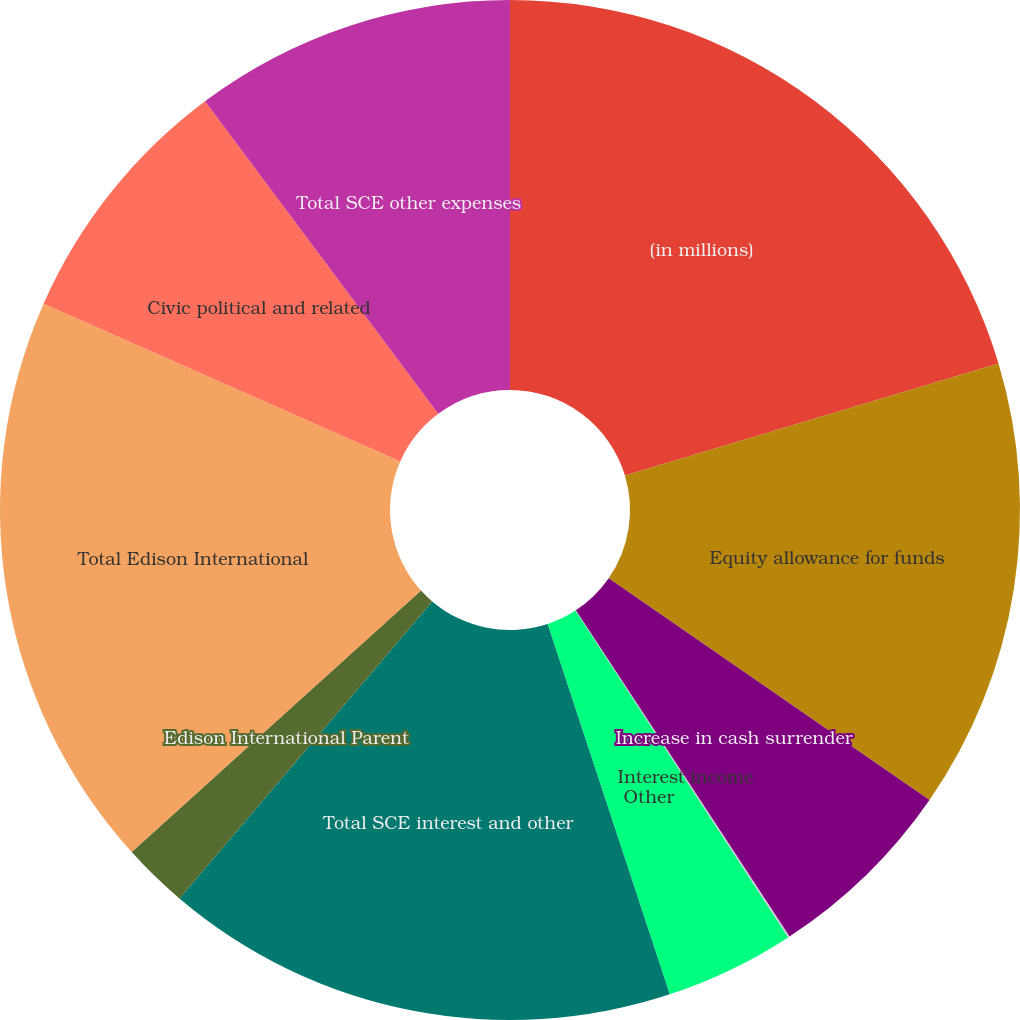<chart> <loc_0><loc_0><loc_500><loc_500><pie_chart><fcel>(in millions)<fcel>Equity allowance for funds<fcel>Increase in cash surrender<fcel>Interest income<fcel>Other<fcel>Total SCE interest and other<fcel>Edison International Parent<fcel>Total Edison International<fcel>Civic political and related<fcel>Total SCE other expenses<nl><fcel>20.36%<fcel>14.26%<fcel>6.14%<fcel>0.05%<fcel>4.11%<fcel>16.29%<fcel>2.08%<fcel>18.32%<fcel>8.17%<fcel>10.2%<nl></chart> 